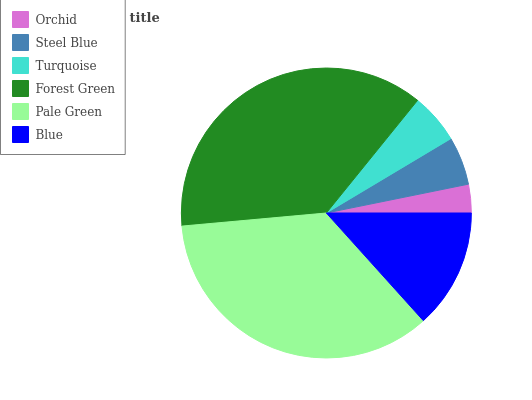Is Orchid the minimum?
Answer yes or no. Yes. Is Forest Green the maximum?
Answer yes or no. Yes. Is Steel Blue the minimum?
Answer yes or no. No. Is Steel Blue the maximum?
Answer yes or no. No. Is Steel Blue greater than Orchid?
Answer yes or no. Yes. Is Orchid less than Steel Blue?
Answer yes or no. Yes. Is Orchid greater than Steel Blue?
Answer yes or no. No. Is Steel Blue less than Orchid?
Answer yes or no. No. Is Blue the high median?
Answer yes or no. Yes. Is Turquoise the low median?
Answer yes or no. Yes. Is Steel Blue the high median?
Answer yes or no. No. Is Forest Green the low median?
Answer yes or no. No. 